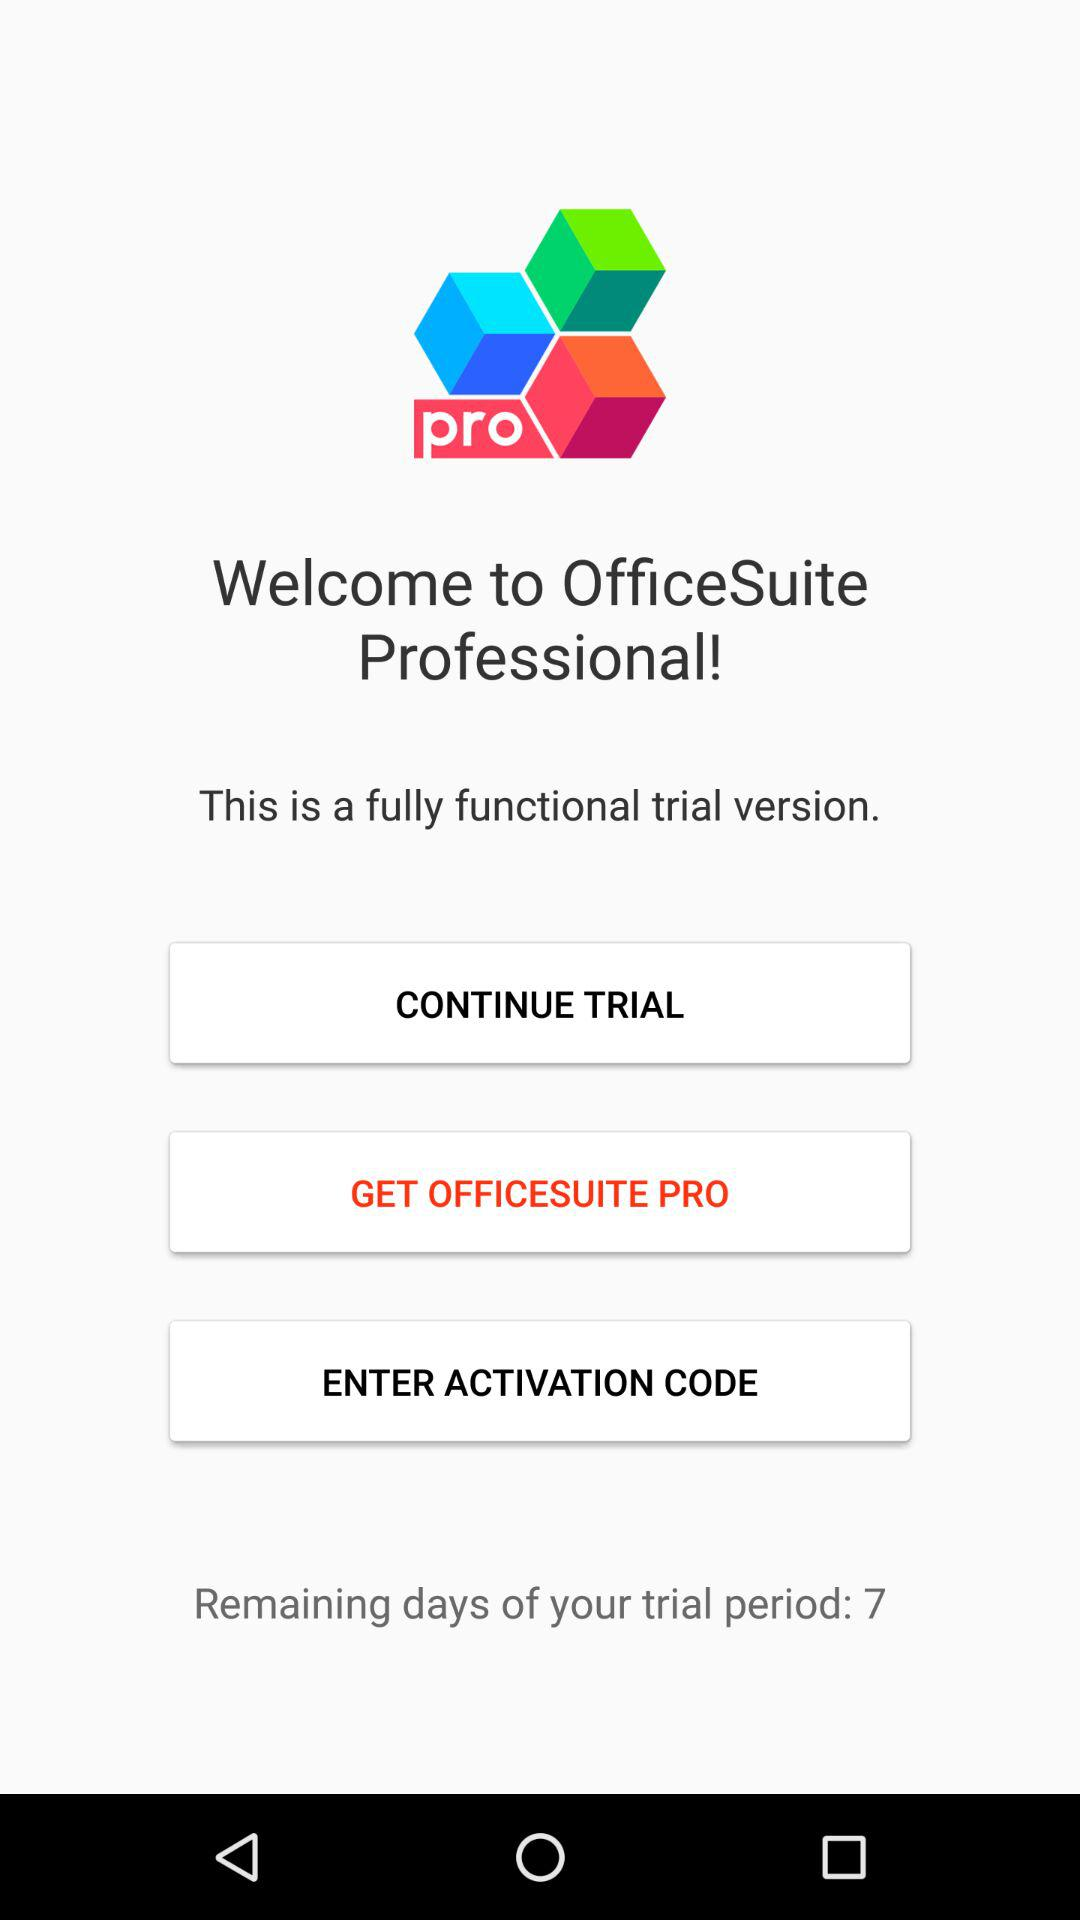How many days are left for the trial period? There are 7 days left for the free trail. 